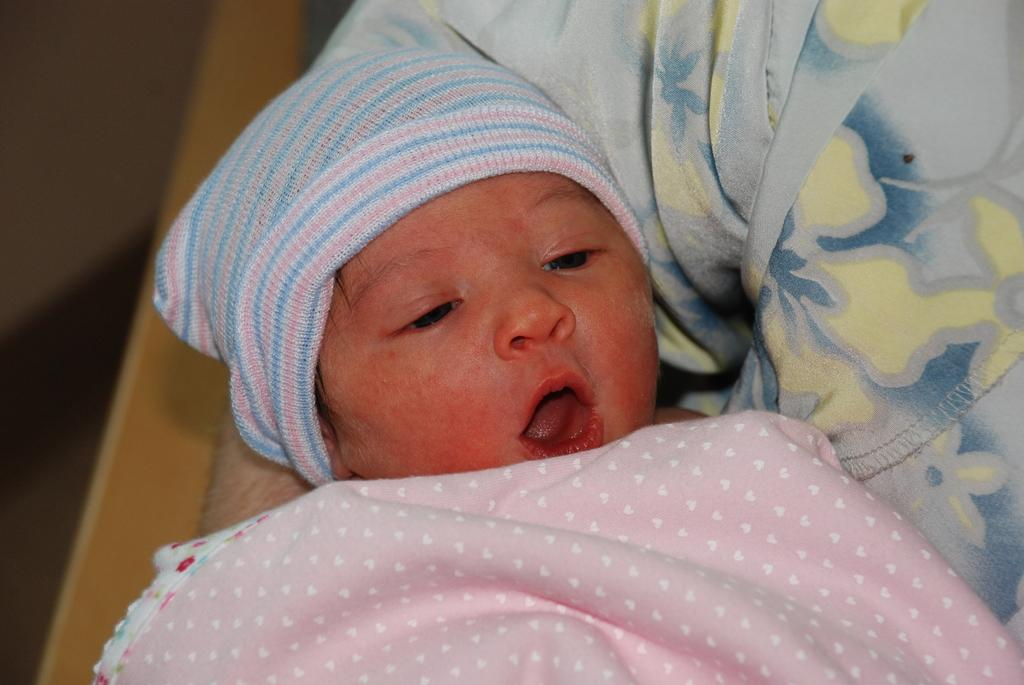Who is the main subject in the picture? There is a person in the picture. What is the person doing in the image? The person is carrying a baby. Can you describe the baby's appearance? The baby is wearing a cap and is wrapped in a pink color towel. What is the cause of death for the baby in the image? There is no indication of death in the image; the baby is being carried by a person and appears to be alive. 